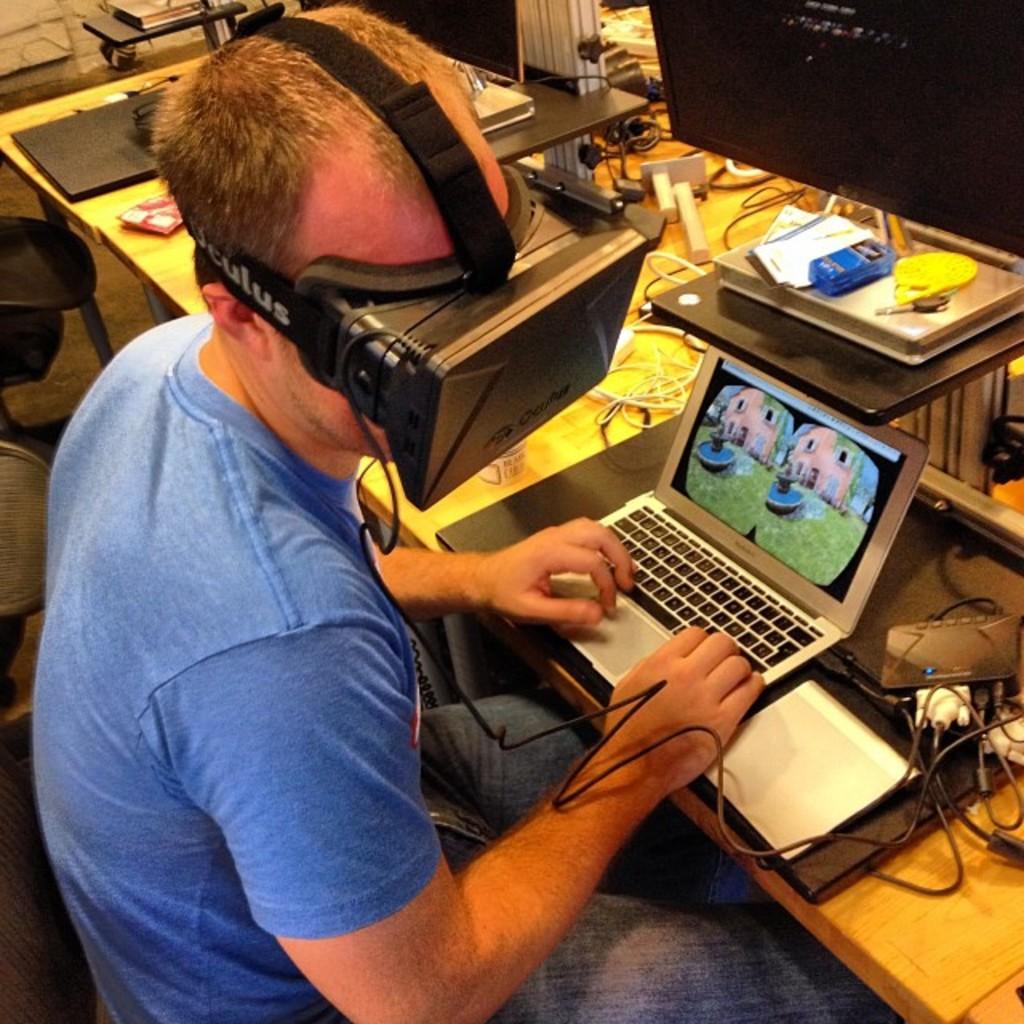Does that head strap say oculus on it?
Offer a terse response. Yes. Is he using the keyboard as a gamepad controller for the device?
Make the answer very short. Answering does not require reading text in the image. 